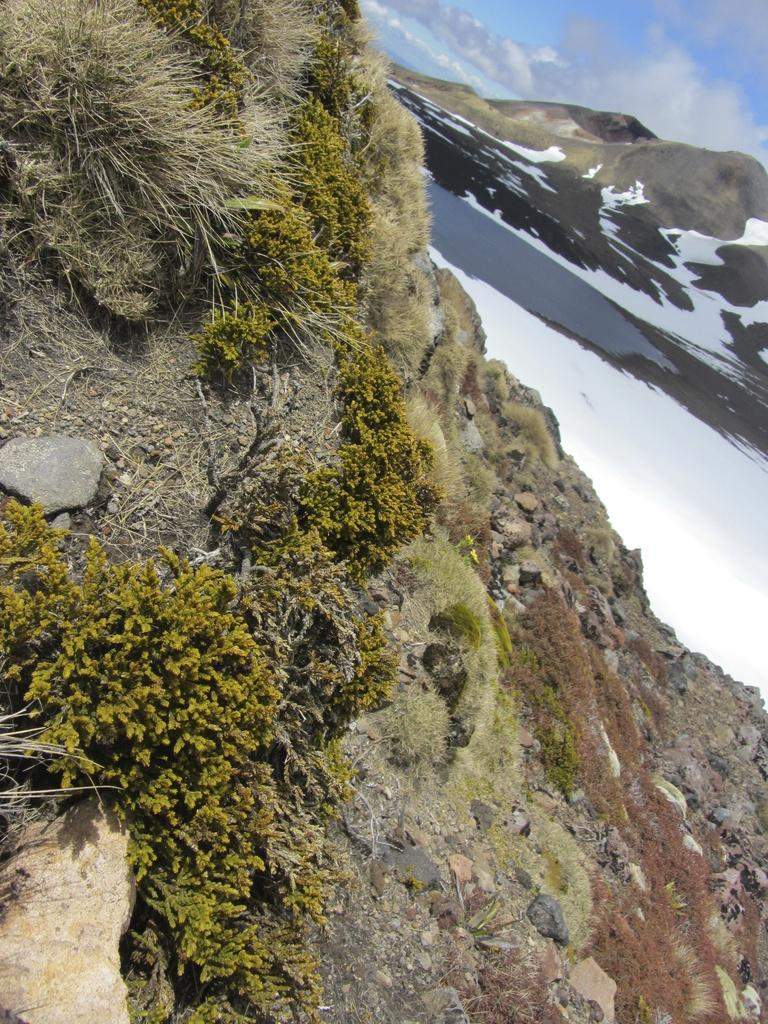What type of natural formation can be seen in the image? There are mountains in the image. What part of the natural environment is visible in the image? The sky is visible on the right side top of the image. How many trees are visible on the mountain in the image? There is no mention of trees on the mountain in the image. What type of shoe can be seen on the mountain in the image? There is no shoe present in the image. 